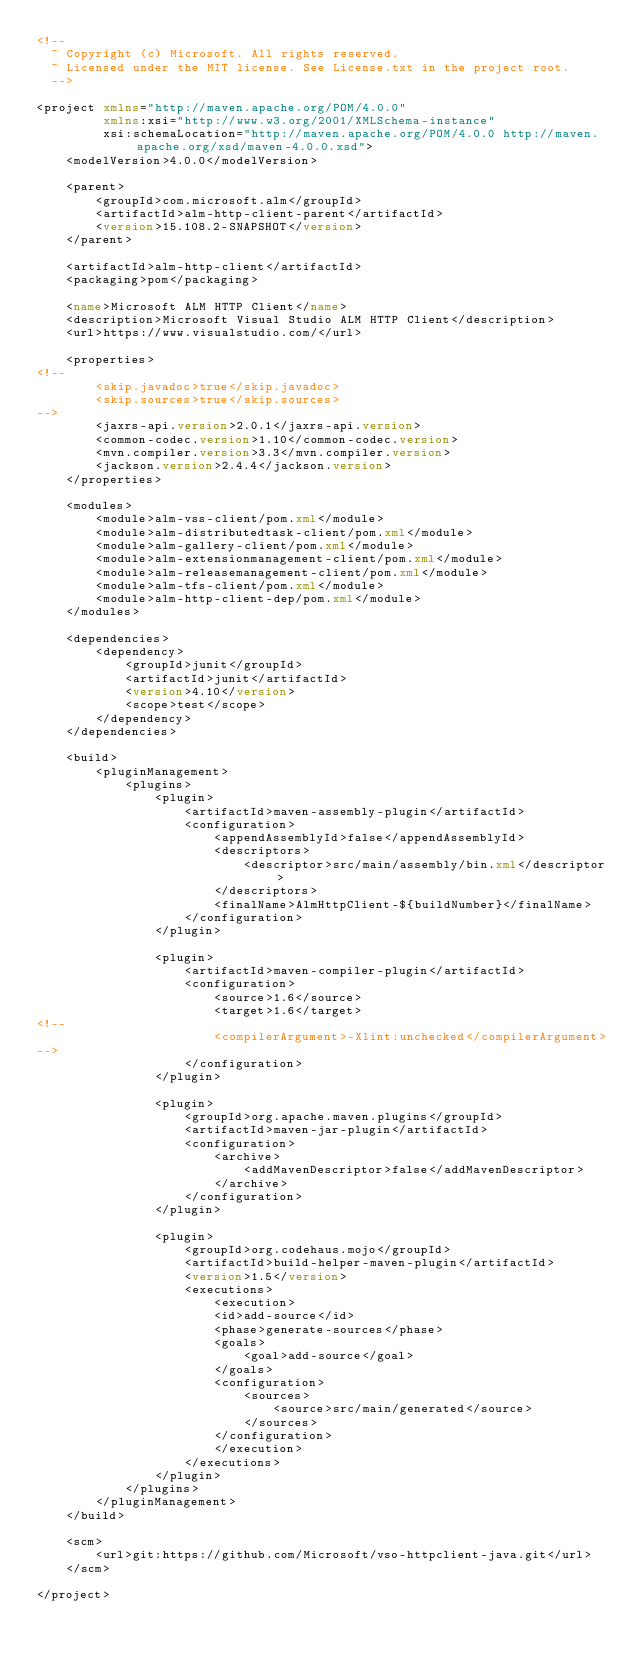Convert code to text. <code><loc_0><loc_0><loc_500><loc_500><_XML_><!--
  ~ Copyright (c) Microsoft. All rights reserved.
  ~ Licensed under the MIT license. See License.txt in the project root.
  -->

<project xmlns="http://maven.apache.org/POM/4.0.0"
         xmlns:xsi="http://www.w3.org/2001/XMLSchema-instance"
         xsi:schemaLocation="http://maven.apache.org/POM/4.0.0 http://maven.apache.org/xsd/maven-4.0.0.xsd">
    <modelVersion>4.0.0</modelVersion>

    <parent>
        <groupId>com.microsoft.alm</groupId>
        <artifactId>alm-http-client-parent</artifactId>
        <version>15.108.2-SNAPSHOT</version>
    </parent>

    <artifactId>alm-http-client</artifactId>
    <packaging>pom</packaging>

    <name>Microsoft ALM HTTP Client</name>
    <description>Microsoft Visual Studio ALM HTTP Client</description>
    <url>https://www.visualstudio.com/</url>

    <properties>
<!--
        <skip.javadoc>true</skip.javadoc>
        <skip.sources>true</skip.sources>
-->
        <jaxrs-api.version>2.0.1</jaxrs-api.version>
        <common-codec.version>1.10</common-codec.version>
        <mvn.compiler.version>3.3</mvn.compiler.version>
        <jackson.version>2.4.4</jackson.version>
    </properties>

    <modules>
        <module>alm-vss-client/pom.xml</module>
        <module>alm-distributedtask-client/pom.xml</module>
        <module>alm-gallery-client/pom.xml</module>
        <module>alm-extensionmanagement-client/pom.xml</module>
        <module>alm-releasemanagement-client/pom.xml</module>
        <module>alm-tfs-client/pom.xml</module>
        <module>alm-http-client-dep/pom.xml</module>
    </modules>

    <dependencies>
        <dependency>
            <groupId>junit</groupId>
            <artifactId>junit</artifactId>
            <version>4.10</version>
            <scope>test</scope>
        </dependency>
    </dependencies>

    <build>
        <pluginManagement>
            <plugins>
                <plugin>
                    <artifactId>maven-assembly-plugin</artifactId>
                    <configuration>
                        <appendAssemblyId>false</appendAssemblyId>
                        <descriptors>
                            <descriptor>src/main/assembly/bin.xml</descriptor>
                        </descriptors>
                        <finalName>AlmHttpClient-${buildNumber}</finalName>
                    </configuration>
                </plugin>

                <plugin>
                    <artifactId>maven-compiler-plugin</artifactId>
                    <configuration>
                        <source>1.6</source>
                        <target>1.6</target>
<!--
                        <compilerArgument>-Xlint:unchecked</compilerArgument> 
-->
                    </configuration>
                </plugin>

                <plugin>
                    <groupId>org.apache.maven.plugins</groupId>
                    <artifactId>maven-jar-plugin</artifactId>
                    <configuration>
                        <archive>
                            <addMavenDescriptor>false</addMavenDescriptor>
                        </archive>
                    </configuration>
                </plugin>

                <plugin>
                    <groupId>org.codehaus.mojo</groupId>
                    <artifactId>build-helper-maven-plugin</artifactId>
                    <version>1.5</version>
                    <executions>
                        <execution>
                        <id>add-source</id>
                        <phase>generate-sources</phase>
                        <goals>
                            <goal>add-source</goal>
                        </goals>
                        <configuration>
                            <sources>
                                <source>src/main/generated</source>
                            </sources>
                        </configuration>
                        </execution>
                    </executions>
                </plugin>
            </plugins>
        </pluginManagement>
    </build>

    <scm> 
        <url>git:https://github.com/Microsoft/vso-httpclient-java.git</url>
    </scm> 

</project>
</code> 